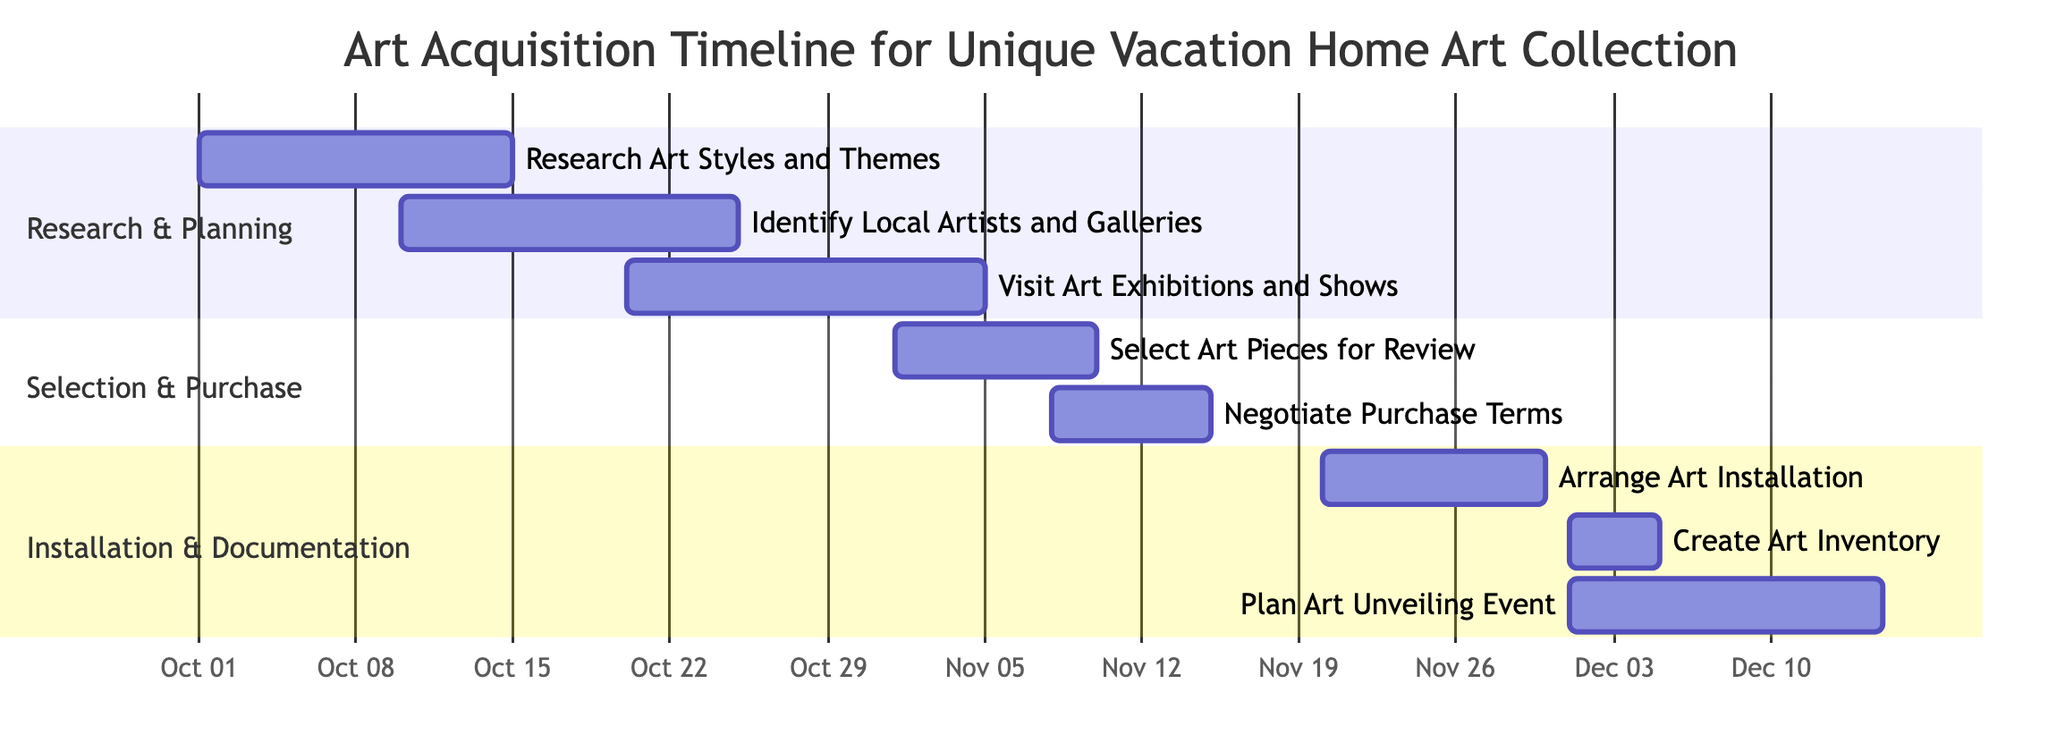What is the duration of the "Research Art Styles and Themes" task? The task "Research Art Styles and Themes" starts on October 1, 2023, and ends on October 15, 2023. To find the duration, we calculate the time between these two dates, which is 15 days.
Answer: 15 days Which task overlaps with the "Identify Local Artists and Art Galleries" task? The task "Visit Art Exhibitions and Shows" starts on October 20, 2023, and overlaps with "Identify Local Artists and Art Galleries," which ends on October 25, 2023. This means there is a 5-day overlap between these two tasks.
Answer: Visit Art Exhibitions and Shows How many tasks are scheduled in the "Research & Planning" section? The "Research & Planning" section contains three tasks: "Research Art Styles and Themes," "Identify Local Artists and Galleries," and "Visit Art Exhibitions and Shows." Counting these, we find that there are three tasks in this section.
Answer: 3 tasks When does the "Arrange Art Installation" task start? Referring to the diagram, the "Arrange Art Installation" task is indicated to start on November 20, 2023. This is explicitly shown in the Gantt chart for that specific task.
Answer: November 20, 2023 What is the last task in the "Installation & Documentation" section? The last task listed in the "Installation & Documentation" section is "Plan Art Unveiling Event," which spans from December 1 to December 15, 2023. Therefore, it is the final task in this section.
Answer: Plan Art Unveiling Event Which tasks share the same start date? The tasks "Create Art Inventory and Documentation" and "Plan Art Unveiling Event" both start on December 1, 2023. Observing the timeline, we see these two tasks begin simultaneously.
Answer: Create Art Inventory and Plan Art Unveiling Event What is the total length of time allocated for the "Selection & Purchase" section? The "Selection & Purchase" section consists of two tasks: "Select Art Pieces for Review," which lasts 10 days, and "Negotiate Purchase Terms," which lasts 8 days. Adding these together gives a total length of 18 days for this section.
Answer: 18 days What is the start date of the last task in the entire timeline? The last task in the entire timeline is "Plan Art Unveiling Event," which begins on December 1, 2023. Checking the timeline, we confirm this starting date.
Answer: December 1, 2023 